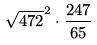<formula> <loc_0><loc_0><loc_500><loc_500>\sqrt { 4 7 2 } ^ { 2 } \cdot \frac { 2 4 7 } { 6 5 }</formula> 